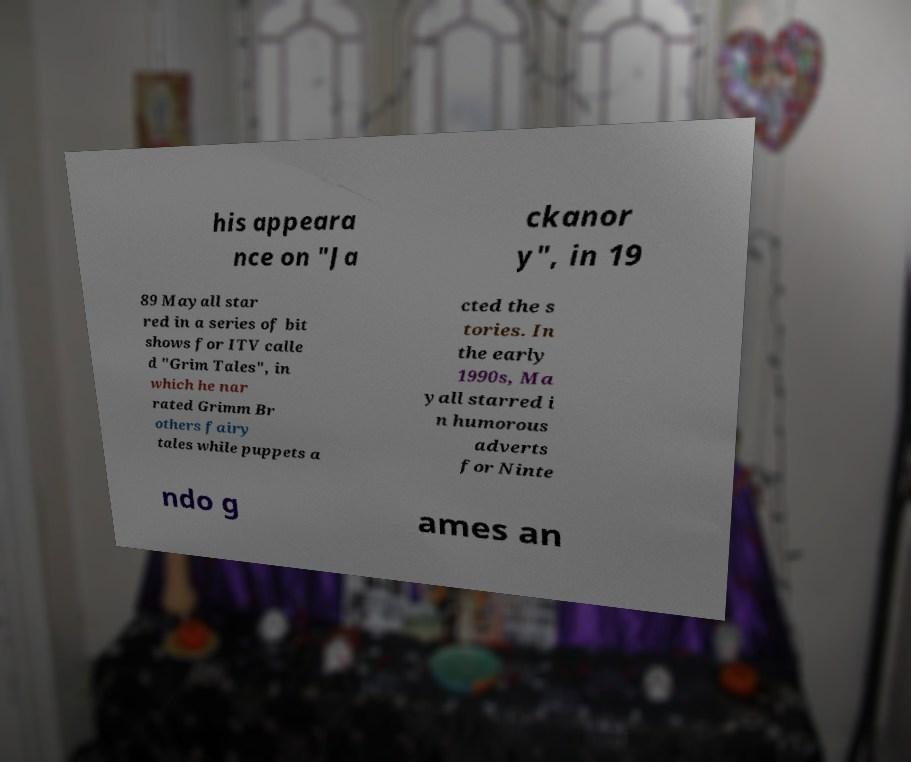What messages or text are displayed in this image? I need them in a readable, typed format. his appeara nce on "Ja ckanor y", in 19 89 Mayall star red in a series of bit shows for ITV calle d "Grim Tales", in which he nar rated Grimm Br others fairy tales while puppets a cted the s tories. In the early 1990s, Ma yall starred i n humorous adverts for Ninte ndo g ames an 